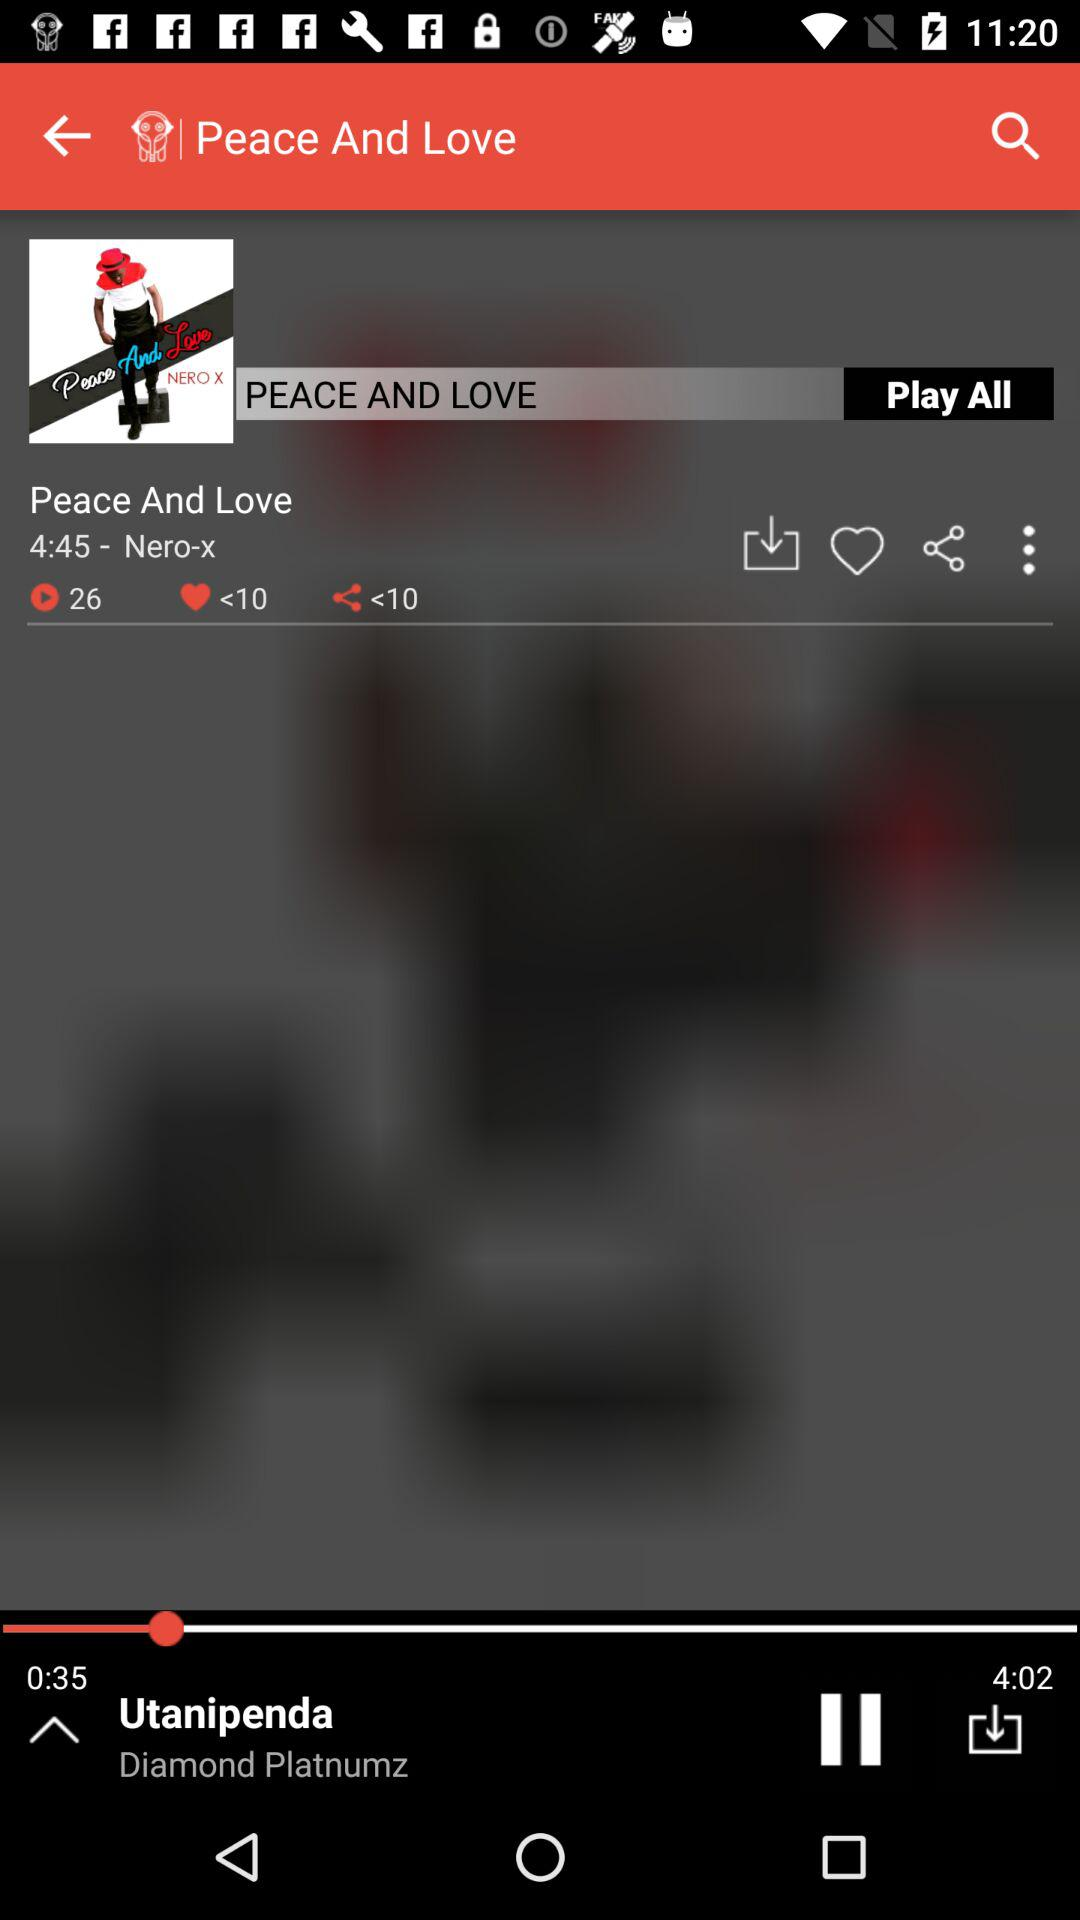How long has the song been played? The song has been played for 35 seconds. 